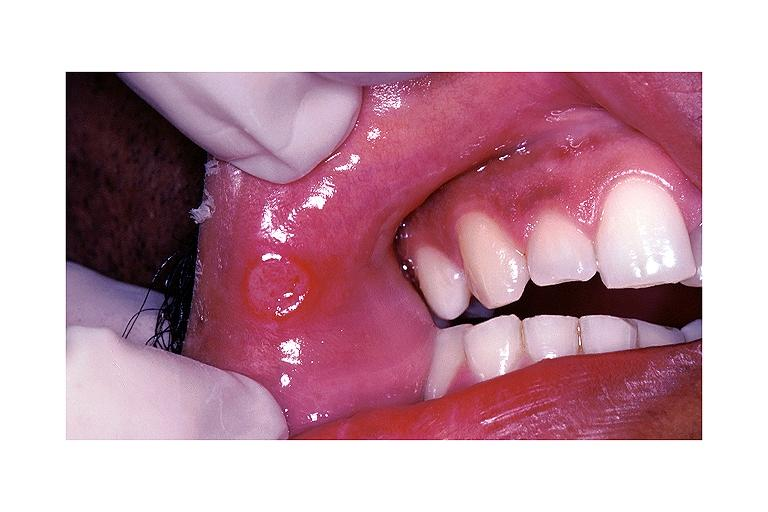s subdiaphragmatic abscess present?
Answer the question using a single word or phrase. No 